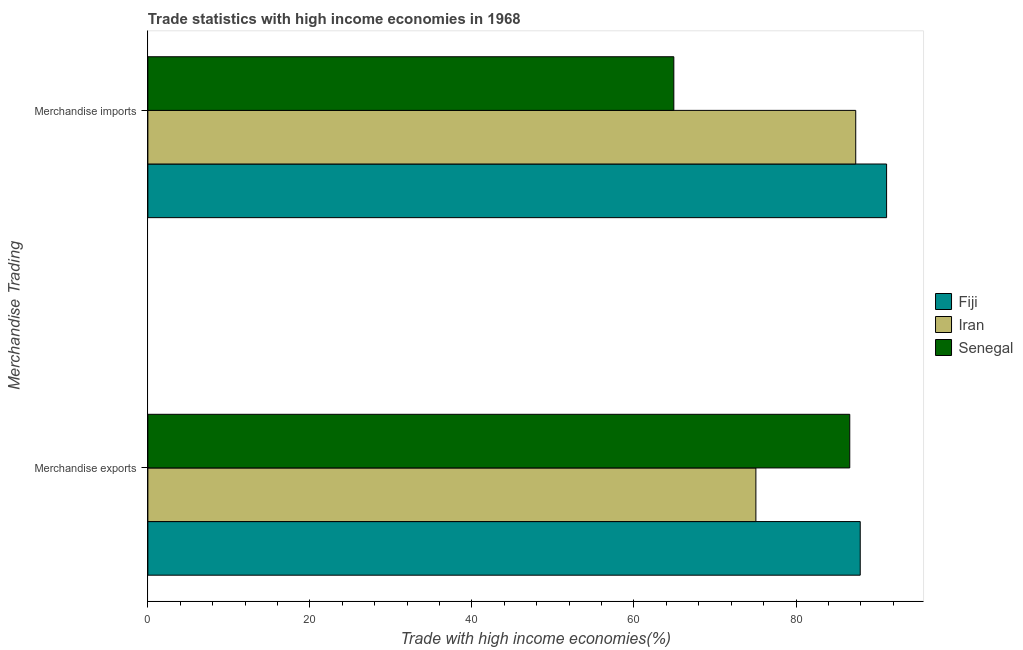How many different coloured bars are there?
Make the answer very short. 3. How many groups of bars are there?
Provide a succinct answer. 2. How many bars are there on the 1st tick from the top?
Your answer should be compact. 3. How many bars are there on the 2nd tick from the bottom?
Provide a succinct answer. 3. What is the merchandise imports in Fiji?
Keep it short and to the point. 91.18. Across all countries, what is the maximum merchandise exports?
Your answer should be compact. 87.93. Across all countries, what is the minimum merchandise imports?
Ensure brevity in your answer.  64.92. In which country was the merchandise imports maximum?
Your answer should be very brief. Fiji. In which country was the merchandise exports minimum?
Provide a succinct answer. Iran. What is the total merchandise imports in the graph?
Give a very brief answer. 243.47. What is the difference between the merchandise exports in Senegal and that in Fiji?
Offer a terse response. -1.29. What is the difference between the merchandise exports in Fiji and the merchandise imports in Iran?
Offer a terse response. 0.55. What is the average merchandise imports per country?
Your answer should be compact. 81.16. What is the difference between the merchandise exports and merchandise imports in Fiji?
Your answer should be very brief. -3.25. What is the ratio of the merchandise exports in Iran to that in Senegal?
Give a very brief answer. 0.87. Is the merchandise exports in Fiji less than that in Iran?
Ensure brevity in your answer.  No. In how many countries, is the merchandise exports greater than the average merchandise exports taken over all countries?
Provide a short and direct response. 2. What does the 3rd bar from the top in Merchandise exports represents?
Keep it short and to the point. Fiji. What does the 2nd bar from the bottom in Merchandise imports represents?
Provide a succinct answer. Iran. What is the difference between two consecutive major ticks on the X-axis?
Provide a short and direct response. 20. Does the graph contain grids?
Offer a terse response. No. How many legend labels are there?
Offer a very short reply. 3. What is the title of the graph?
Provide a short and direct response. Trade statistics with high income economies in 1968. Does "Aruba" appear as one of the legend labels in the graph?
Keep it short and to the point. No. What is the label or title of the X-axis?
Your response must be concise. Trade with high income economies(%). What is the label or title of the Y-axis?
Give a very brief answer. Merchandise Trading. What is the Trade with high income economies(%) in Fiji in Merchandise exports?
Offer a very short reply. 87.93. What is the Trade with high income economies(%) of Iran in Merchandise exports?
Keep it short and to the point. 75.05. What is the Trade with high income economies(%) in Senegal in Merchandise exports?
Ensure brevity in your answer.  86.64. What is the Trade with high income economies(%) of Fiji in Merchandise imports?
Your answer should be very brief. 91.18. What is the Trade with high income economies(%) of Iran in Merchandise imports?
Your answer should be compact. 87.37. What is the Trade with high income economies(%) of Senegal in Merchandise imports?
Provide a short and direct response. 64.92. Across all Merchandise Trading, what is the maximum Trade with high income economies(%) of Fiji?
Your answer should be compact. 91.18. Across all Merchandise Trading, what is the maximum Trade with high income economies(%) of Iran?
Your answer should be compact. 87.37. Across all Merchandise Trading, what is the maximum Trade with high income economies(%) of Senegal?
Offer a terse response. 86.64. Across all Merchandise Trading, what is the minimum Trade with high income economies(%) of Fiji?
Make the answer very short. 87.93. Across all Merchandise Trading, what is the minimum Trade with high income economies(%) of Iran?
Give a very brief answer. 75.05. Across all Merchandise Trading, what is the minimum Trade with high income economies(%) of Senegal?
Ensure brevity in your answer.  64.92. What is the total Trade with high income economies(%) in Fiji in the graph?
Your answer should be compact. 179.11. What is the total Trade with high income economies(%) in Iran in the graph?
Your answer should be very brief. 162.42. What is the total Trade with high income economies(%) in Senegal in the graph?
Your answer should be very brief. 151.55. What is the difference between the Trade with high income economies(%) of Fiji in Merchandise exports and that in Merchandise imports?
Your answer should be compact. -3.25. What is the difference between the Trade with high income economies(%) in Iran in Merchandise exports and that in Merchandise imports?
Offer a terse response. -12.32. What is the difference between the Trade with high income economies(%) of Senegal in Merchandise exports and that in Merchandise imports?
Your answer should be very brief. 21.72. What is the difference between the Trade with high income economies(%) in Fiji in Merchandise exports and the Trade with high income economies(%) in Iran in Merchandise imports?
Offer a terse response. 0.56. What is the difference between the Trade with high income economies(%) in Fiji in Merchandise exports and the Trade with high income economies(%) in Senegal in Merchandise imports?
Provide a short and direct response. 23.01. What is the difference between the Trade with high income economies(%) in Iran in Merchandise exports and the Trade with high income economies(%) in Senegal in Merchandise imports?
Keep it short and to the point. 10.13. What is the average Trade with high income economies(%) in Fiji per Merchandise Trading?
Give a very brief answer. 89.55. What is the average Trade with high income economies(%) in Iran per Merchandise Trading?
Ensure brevity in your answer.  81.21. What is the average Trade with high income economies(%) of Senegal per Merchandise Trading?
Provide a short and direct response. 75.78. What is the difference between the Trade with high income economies(%) of Fiji and Trade with high income economies(%) of Iran in Merchandise exports?
Provide a short and direct response. 12.88. What is the difference between the Trade with high income economies(%) of Fiji and Trade with high income economies(%) of Senegal in Merchandise exports?
Offer a terse response. 1.29. What is the difference between the Trade with high income economies(%) in Iran and Trade with high income economies(%) in Senegal in Merchandise exports?
Your response must be concise. -11.59. What is the difference between the Trade with high income economies(%) in Fiji and Trade with high income economies(%) in Iran in Merchandise imports?
Ensure brevity in your answer.  3.81. What is the difference between the Trade with high income economies(%) of Fiji and Trade with high income economies(%) of Senegal in Merchandise imports?
Offer a terse response. 26.26. What is the difference between the Trade with high income economies(%) of Iran and Trade with high income economies(%) of Senegal in Merchandise imports?
Your answer should be very brief. 22.45. What is the ratio of the Trade with high income economies(%) in Fiji in Merchandise exports to that in Merchandise imports?
Provide a short and direct response. 0.96. What is the ratio of the Trade with high income economies(%) in Iran in Merchandise exports to that in Merchandise imports?
Offer a very short reply. 0.86. What is the ratio of the Trade with high income economies(%) in Senegal in Merchandise exports to that in Merchandise imports?
Your answer should be compact. 1.33. What is the difference between the highest and the second highest Trade with high income economies(%) in Fiji?
Keep it short and to the point. 3.25. What is the difference between the highest and the second highest Trade with high income economies(%) of Iran?
Offer a terse response. 12.32. What is the difference between the highest and the second highest Trade with high income economies(%) of Senegal?
Ensure brevity in your answer.  21.72. What is the difference between the highest and the lowest Trade with high income economies(%) in Fiji?
Give a very brief answer. 3.25. What is the difference between the highest and the lowest Trade with high income economies(%) in Iran?
Your answer should be compact. 12.32. What is the difference between the highest and the lowest Trade with high income economies(%) of Senegal?
Offer a very short reply. 21.72. 